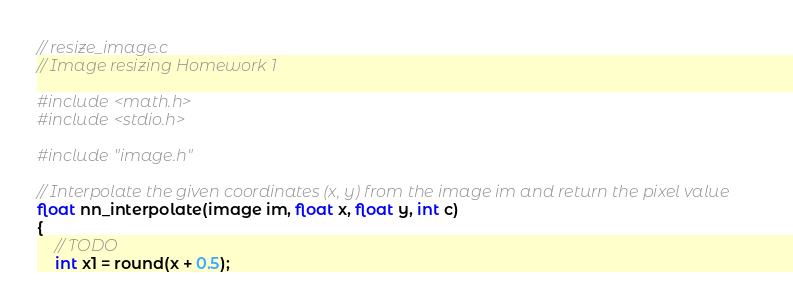<code> <loc_0><loc_0><loc_500><loc_500><_C_>// resize_image.c
// Image resizing Homework 1

#include <math.h>
#include <stdio.h>

#include "image.h"

// Interpolate the given coordinates (x, y) from the image im and return the pixel value
float nn_interpolate(image im, float x, float y, int c)
{
    // TODO
    int x1 = round(x + 0.5);</code> 